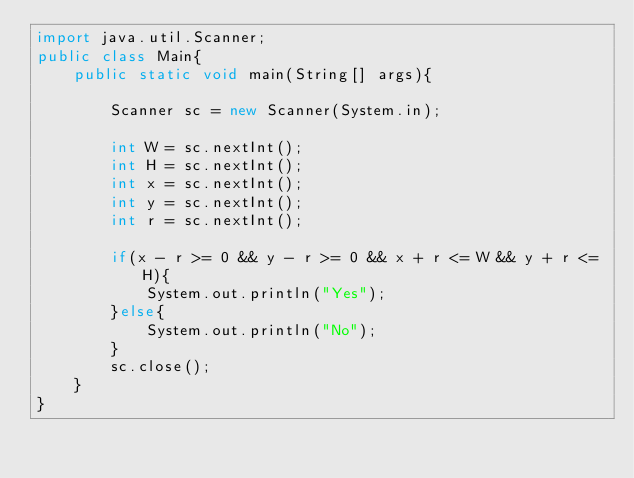Convert code to text. <code><loc_0><loc_0><loc_500><loc_500><_Java_>import java.util.Scanner;
public class Main{
    public static void main(String[] args){
        
        Scanner sc = new Scanner(System.in);
        
        int W = sc.nextInt();
        int H = sc.nextInt();
        int x = sc.nextInt();
        int y = sc.nextInt();
        int r = sc.nextInt();
        
        if(x - r >= 0 && y - r >= 0 && x + r <= W && y + r <= H){
            System.out.println("Yes");
        }else{
            System.out.println("No");
        }
        sc.close();
    }
}

</code> 